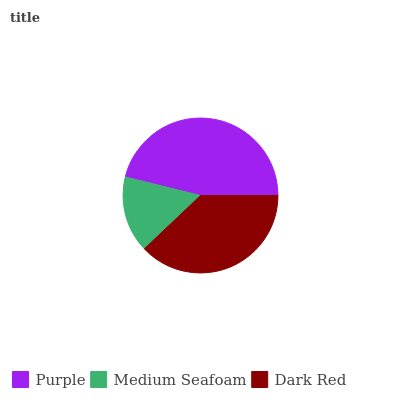Is Medium Seafoam the minimum?
Answer yes or no. Yes. Is Purple the maximum?
Answer yes or no. Yes. Is Dark Red the minimum?
Answer yes or no. No. Is Dark Red the maximum?
Answer yes or no. No. Is Dark Red greater than Medium Seafoam?
Answer yes or no. Yes. Is Medium Seafoam less than Dark Red?
Answer yes or no. Yes. Is Medium Seafoam greater than Dark Red?
Answer yes or no. No. Is Dark Red less than Medium Seafoam?
Answer yes or no. No. Is Dark Red the high median?
Answer yes or no. Yes. Is Dark Red the low median?
Answer yes or no. Yes. Is Purple the high median?
Answer yes or no. No. Is Purple the low median?
Answer yes or no. No. 